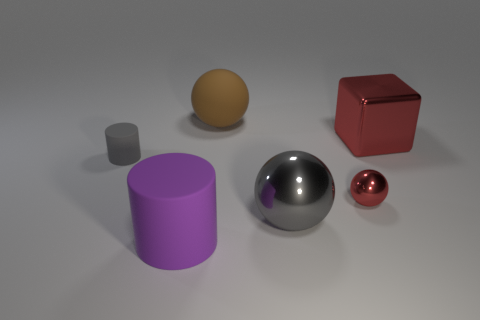What is the size of the shiny ball that is the same color as the block?
Give a very brief answer. Small. There is a thing that is the same color as the small ball; what material is it?
Your answer should be very brief. Metal. What number of other things are there of the same color as the large block?
Provide a short and direct response. 1. There is a purple thing; are there any big rubber objects behind it?
Provide a short and direct response. Yes. There is a small object in front of the small gray matte thing that is to the left of the big sphere that is in front of the gray cylinder; what color is it?
Keep it short and to the point. Red. What number of things are both left of the big cube and on the right side of the big gray ball?
Keep it short and to the point. 1. How many cylinders are red objects or tiny brown objects?
Provide a short and direct response. 0. Is there a big metallic thing?
Provide a succinct answer. Yes. There is a purple object that is the same size as the gray shiny thing; what is its material?
Make the answer very short. Rubber. Do the red object behind the small gray cylinder and the tiny gray thing have the same shape?
Offer a very short reply. No. 